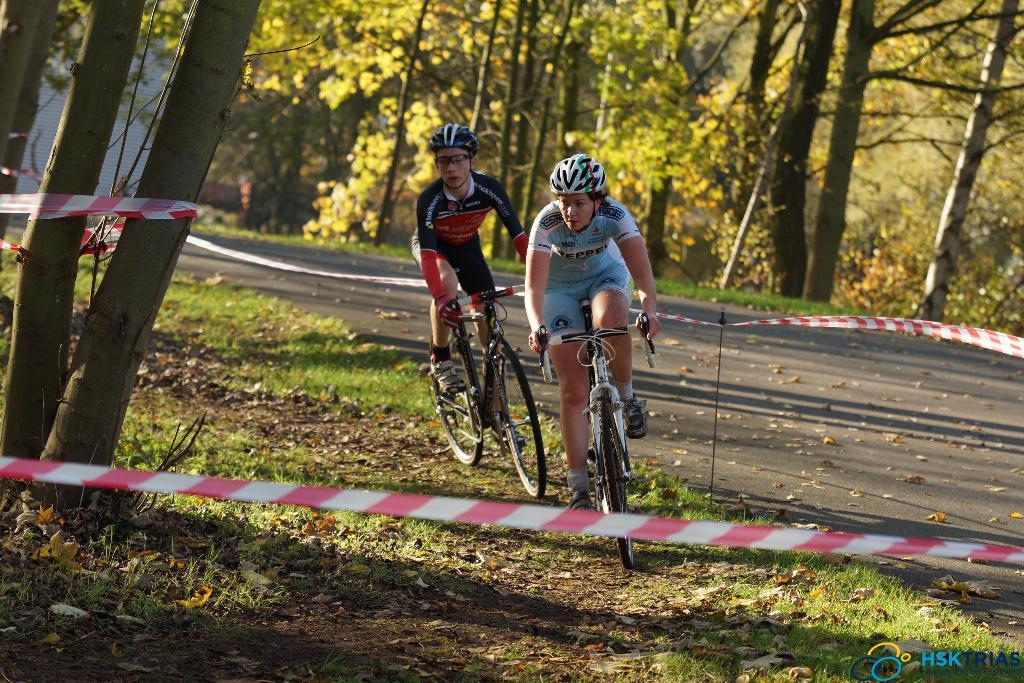How many people are in the image? There are two people in the image. What are the two people doing in the image? The two people are riding a cycle. What is the ground made of in the image? The ground has grass and dry leaves. What can be seen in the background of the image? There are trees and a road with dry leaves in the background. What additional object is present in the image? There is a ribbon in the image. What type of government is depicted in the image? There is no depiction of a government in the image; it features two people riding a cycle and a background with trees and a road. Can you tell me how many times the person on the left kicks the person on the right in the image? There is no kicking action depicted in the image; the two people are riding a cycle together. 